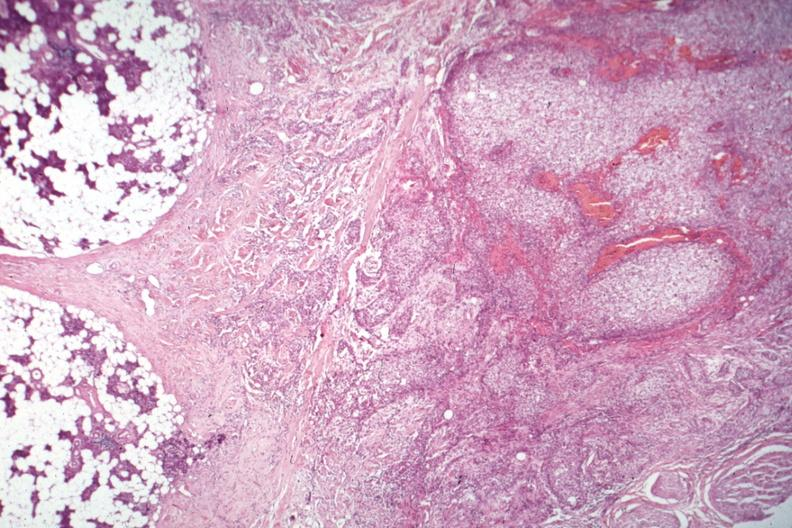does iron show nice photo of parotid on one side with tumor capsule and obvious invasive tumor?
Answer the question using a single word or phrase. No 